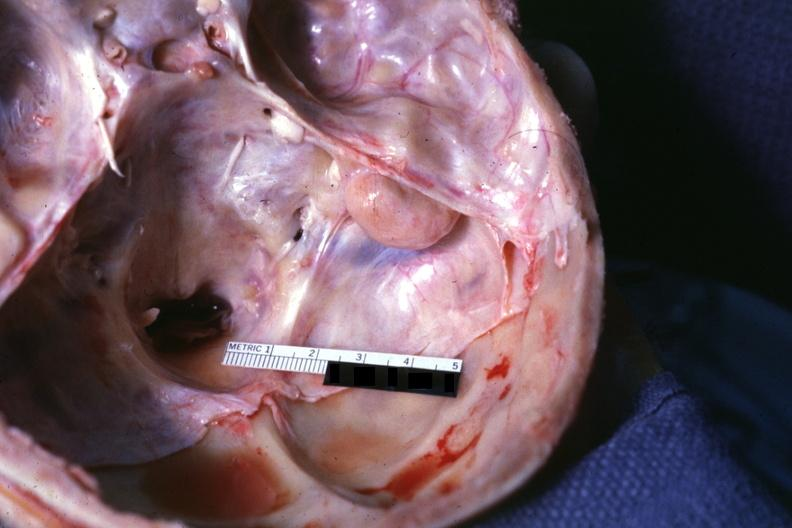what removed?
Answer the question using a single word or phrase. Opened base of skull with brain 